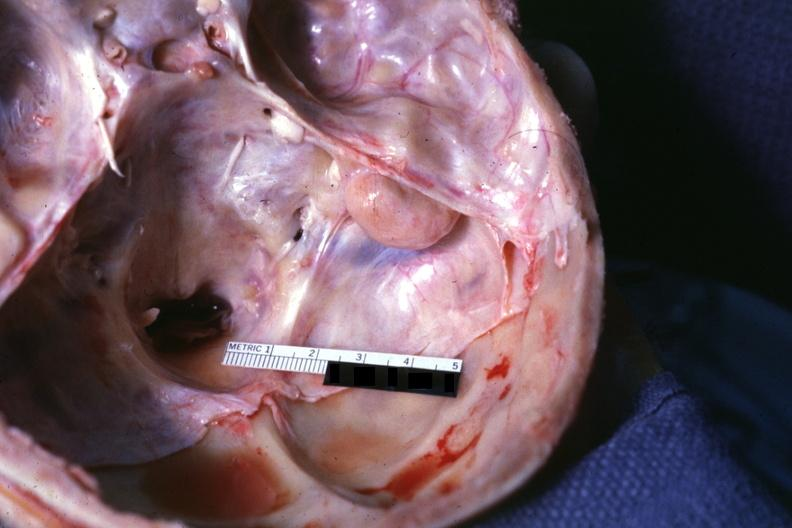what removed?
Answer the question using a single word or phrase. Opened base of skull with brain 